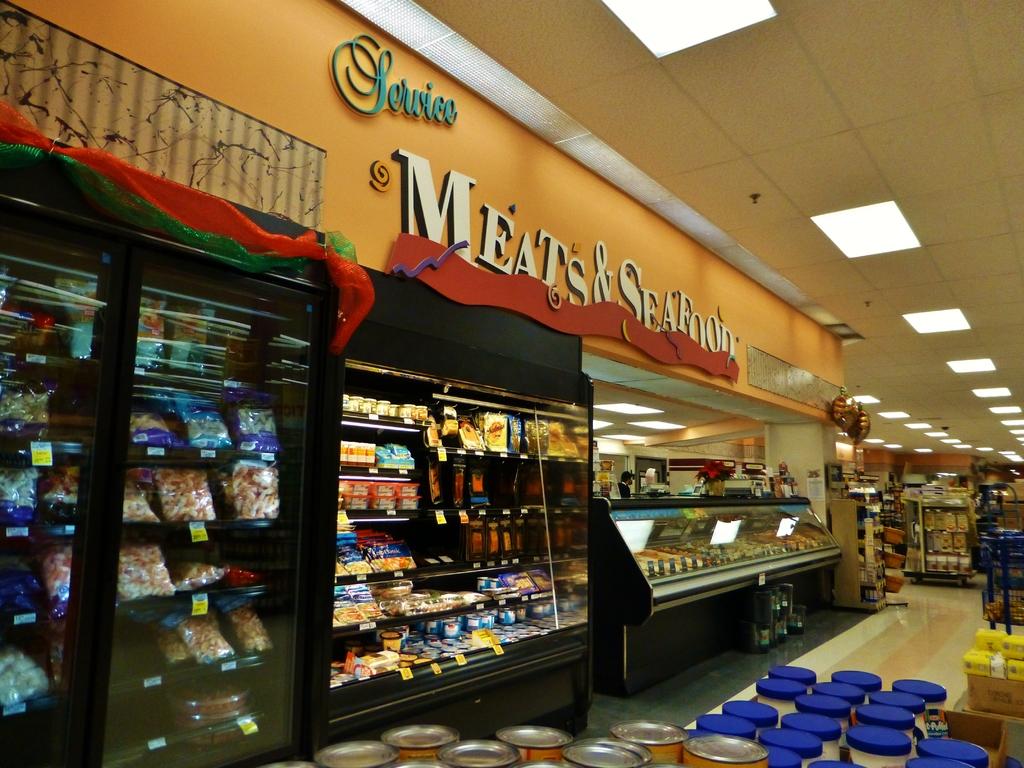What are they selling in this section of the market?
Offer a very short reply. Meats & seafood. Does this section of the market offer service?
Offer a very short reply. Meats and seafood. 